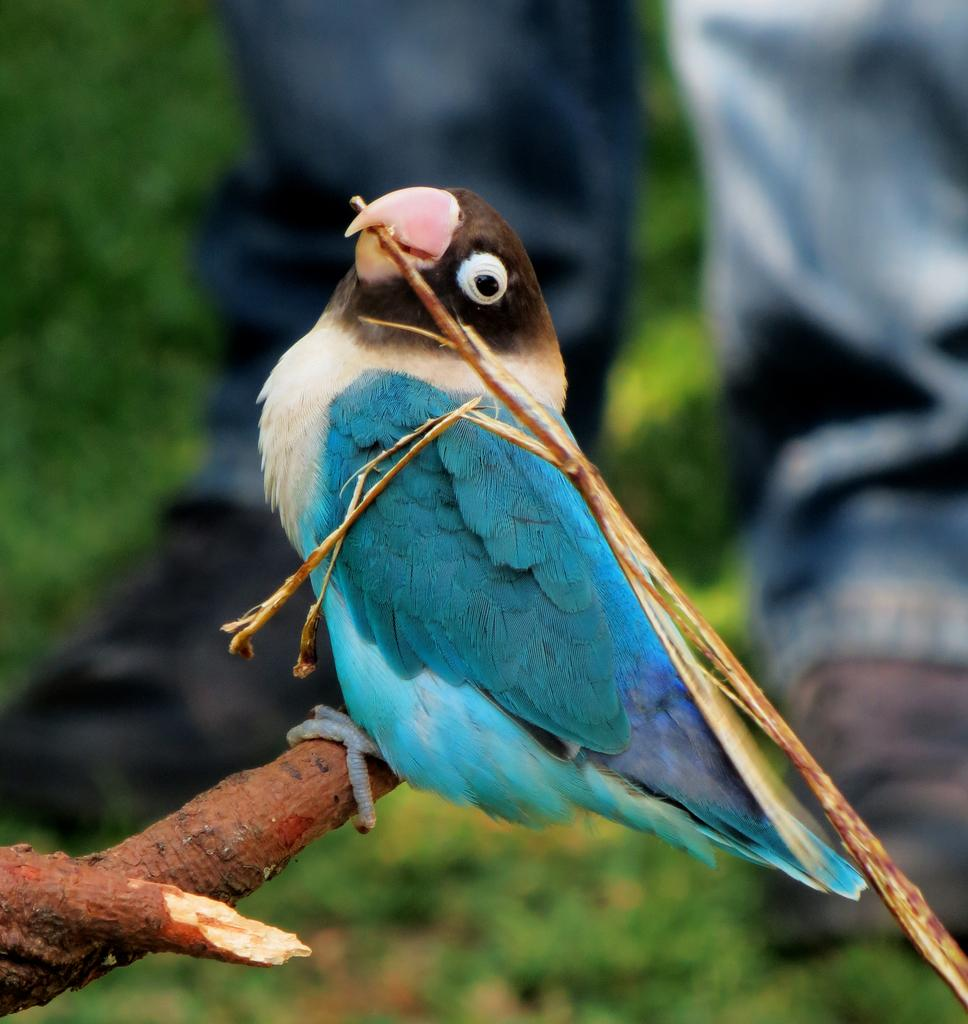What type of animal is in the image? There is a bird in the image. What is the bird perched on? The bird is on a wooden stick. Who else is present in the image? There is a human standing in the image. What is the surface the human is standing on? The human is standing on grass. How would you describe the background of the image? The background of the image is blurry. What type of food is being cooked on the stove in the image? There is no stove or food present in the image. What subject is the human teaching in the image? There is no teaching or subject being taught in the image. 